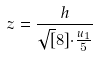Convert formula to latex. <formula><loc_0><loc_0><loc_500><loc_500>z = \frac { h } { \sqrt { [ } 8 ] { \cdot \frac { u _ { 1 } } { 5 } } }</formula> 